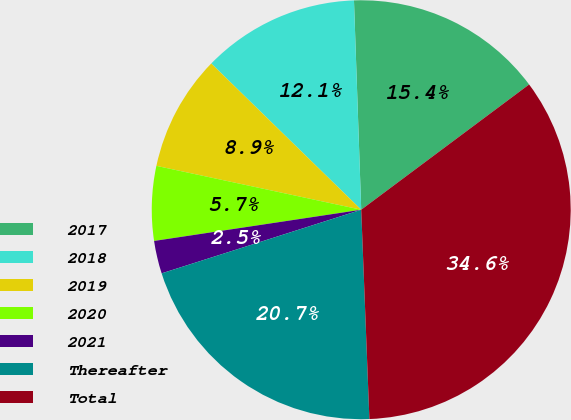Convert chart. <chart><loc_0><loc_0><loc_500><loc_500><pie_chart><fcel>2017<fcel>2018<fcel>2019<fcel>2020<fcel>2021<fcel>Thereafter<fcel>Total<nl><fcel>15.35%<fcel>12.15%<fcel>8.94%<fcel>5.74%<fcel>2.53%<fcel>20.71%<fcel>34.58%<nl></chart> 